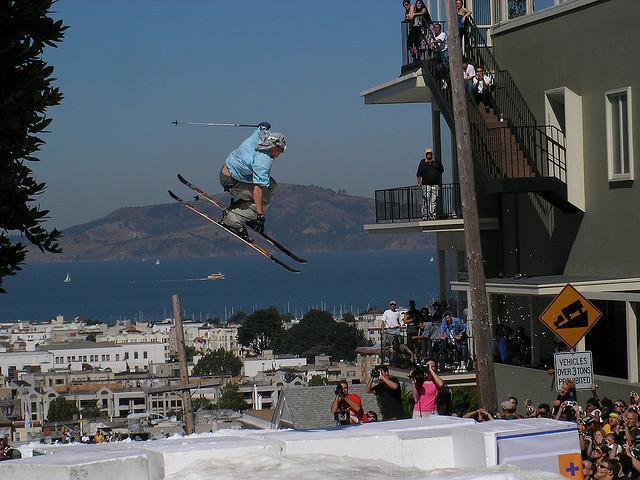How many people are in the picture?
Give a very brief answer. 2. 